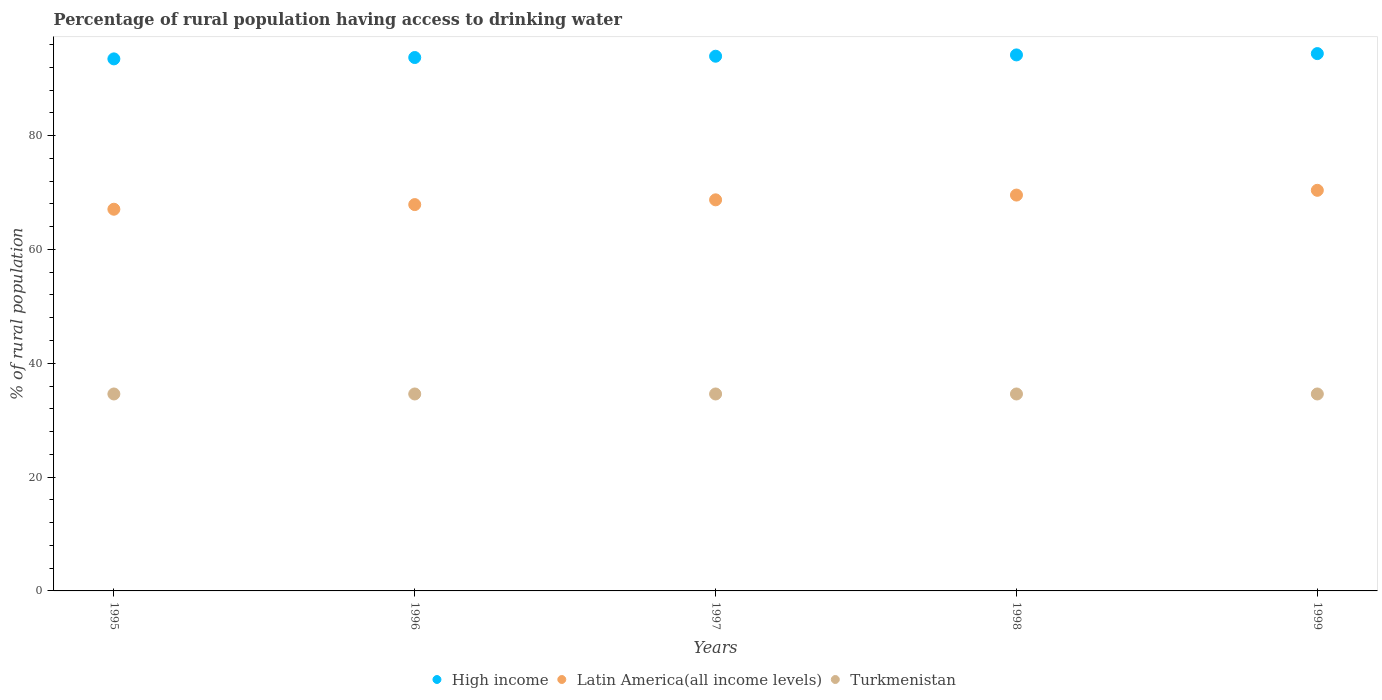Is the number of dotlines equal to the number of legend labels?
Provide a short and direct response. Yes. What is the percentage of rural population having access to drinking water in High income in 1996?
Give a very brief answer. 93.71. Across all years, what is the maximum percentage of rural population having access to drinking water in Latin America(all income levels)?
Provide a short and direct response. 70.38. Across all years, what is the minimum percentage of rural population having access to drinking water in Latin America(all income levels)?
Make the answer very short. 67.06. In which year was the percentage of rural population having access to drinking water in Turkmenistan maximum?
Your answer should be compact. 1995. What is the total percentage of rural population having access to drinking water in High income in the graph?
Make the answer very short. 469.68. What is the difference between the percentage of rural population having access to drinking water in Latin America(all income levels) in 1998 and the percentage of rural population having access to drinking water in High income in 1997?
Offer a very short reply. -24.39. What is the average percentage of rural population having access to drinking water in High income per year?
Offer a very short reply. 93.94. In the year 1996, what is the difference between the percentage of rural population having access to drinking water in High income and percentage of rural population having access to drinking water in Latin America(all income levels)?
Provide a succinct answer. 25.84. In how many years, is the percentage of rural population having access to drinking water in Turkmenistan greater than 20 %?
Ensure brevity in your answer.  5. What is the ratio of the percentage of rural population having access to drinking water in Latin America(all income levels) in 1997 to that in 1999?
Keep it short and to the point. 0.98. Is the percentage of rural population having access to drinking water in Turkmenistan in 1995 less than that in 1999?
Your response must be concise. No. What is the difference between the highest and the second highest percentage of rural population having access to drinking water in High income?
Offer a very short reply. 0.23. In how many years, is the percentage of rural population having access to drinking water in Turkmenistan greater than the average percentage of rural population having access to drinking water in Turkmenistan taken over all years?
Give a very brief answer. 0. Is the sum of the percentage of rural population having access to drinking water in Turkmenistan in 1997 and 1999 greater than the maximum percentage of rural population having access to drinking water in High income across all years?
Keep it short and to the point. No. Is it the case that in every year, the sum of the percentage of rural population having access to drinking water in Turkmenistan and percentage of rural population having access to drinking water in Latin America(all income levels)  is greater than the percentage of rural population having access to drinking water in High income?
Provide a short and direct response. Yes. Does the percentage of rural population having access to drinking water in High income monotonically increase over the years?
Make the answer very short. Yes. Is the percentage of rural population having access to drinking water in Latin America(all income levels) strictly less than the percentage of rural population having access to drinking water in Turkmenistan over the years?
Provide a succinct answer. No. How many dotlines are there?
Your answer should be compact. 3. How many years are there in the graph?
Provide a succinct answer. 5. What is the difference between two consecutive major ticks on the Y-axis?
Give a very brief answer. 20. How many legend labels are there?
Offer a terse response. 3. How are the legend labels stacked?
Give a very brief answer. Horizontal. What is the title of the graph?
Offer a very short reply. Percentage of rural population having access to drinking water. What is the label or title of the X-axis?
Ensure brevity in your answer.  Years. What is the label or title of the Y-axis?
Your answer should be very brief. % of rural population. What is the % of rural population of High income in 1995?
Your response must be concise. 93.47. What is the % of rural population of Latin America(all income levels) in 1995?
Make the answer very short. 67.06. What is the % of rural population in Turkmenistan in 1995?
Your answer should be compact. 34.6. What is the % of rural population in High income in 1996?
Your response must be concise. 93.71. What is the % of rural population of Latin America(all income levels) in 1996?
Give a very brief answer. 67.87. What is the % of rural population in Turkmenistan in 1996?
Provide a short and direct response. 34.6. What is the % of rural population of High income in 1997?
Provide a succinct answer. 93.94. What is the % of rural population in Latin America(all income levels) in 1997?
Your answer should be very brief. 68.71. What is the % of rural population in Turkmenistan in 1997?
Make the answer very short. 34.6. What is the % of rural population in High income in 1998?
Ensure brevity in your answer.  94.17. What is the % of rural population of Latin America(all income levels) in 1998?
Your response must be concise. 69.54. What is the % of rural population in Turkmenistan in 1998?
Keep it short and to the point. 34.6. What is the % of rural population of High income in 1999?
Offer a terse response. 94.4. What is the % of rural population of Latin America(all income levels) in 1999?
Provide a short and direct response. 70.38. What is the % of rural population of Turkmenistan in 1999?
Ensure brevity in your answer.  34.6. Across all years, what is the maximum % of rural population in High income?
Your response must be concise. 94.4. Across all years, what is the maximum % of rural population in Latin America(all income levels)?
Your answer should be compact. 70.38. Across all years, what is the maximum % of rural population in Turkmenistan?
Provide a succinct answer. 34.6. Across all years, what is the minimum % of rural population in High income?
Ensure brevity in your answer.  93.47. Across all years, what is the minimum % of rural population of Latin America(all income levels)?
Provide a short and direct response. 67.06. Across all years, what is the minimum % of rural population of Turkmenistan?
Offer a very short reply. 34.6. What is the total % of rural population of High income in the graph?
Provide a succinct answer. 469.68. What is the total % of rural population of Latin America(all income levels) in the graph?
Keep it short and to the point. 343.56. What is the total % of rural population of Turkmenistan in the graph?
Offer a terse response. 173. What is the difference between the % of rural population in High income in 1995 and that in 1996?
Give a very brief answer. -0.24. What is the difference between the % of rural population of Latin America(all income levels) in 1995 and that in 1996?
Your answer should be very brief. -0.82. What is the difference between the % of rural population in High income in 1995 and that in 1997?
Your response must be concise. -0.47. What is the difference between the % of rural population in Latin America(all income levels) in 1995 and that in 1997?
Offer a very short reply. -1.65. What is the difference between the % of rural population of High income in 1995 and that in 1998?
Make the answer very short. -0.7. What is the difference between the % of rural population of Latin America(all income levels) in 1995 and that in 1998?
Offer a very short reply. -2.49. What is the difference between the % of rural population in Turkmenistan in 1995 and that in 1998?
Your response must be concise. 0. What is the difference between the % of rural population in High income in 1995 and that in 1999?
Your answer should be compact. -0.93. What is the difference between the % of rural population in Latin America(all income levels) in 1995 and that in 1999?
Ensure brevity in your answer.  -3.32. What is the difference between the % of rural population in Turkmenistan in 1995 and that in 1999?
Give a very brief answer. 0. What is the difference between the % of rural population in High income in 1996 and that in 1997?
Your answer should be compact. -0.23. What is the difference between the % of rural population of Latin America(all income levels) in 1996 and that in 1997?
Your answer should be compact. -0.84. What is the difference between the % of rural population of Turkmenistan in 1996 and that in 1997?
Keep it short and to the point. 0. What is the difference between the % of rural population of High income in 1996 and that in 1998?
Give a very brief answer. -0.46. What is the difference between the % of rural population of Latin America(all income levels) in 1996 and that in 1998?
Offer a very short reply. -1.67. What is the difference between the % of rural population in High income in 1996 and that in 1999?
Keep it short and to the point. -0.69. What is the difference between the % of rural population of Latin America(all income levels) in 1996 and that in 1999?
Keep it short and to the point. -2.51. What is the difference between the % of rural population of Turkmenistan in 1996 and that in 1999?
Provide a short and direct response. 0. What is the difference between the % of rural population of High income in 1997 and that in 1998?
Give a very brief answer. -0.23. What is the difference between the % of rural population in Latin America(all income levels) in 1997 and that in 1998?
Provide a succinct answer. -0.84. What is the difference between the % of rural population of Turkmenistan in 1997 and that in 1998?
Make the answer very short. 0. What is the difference between the % of rural population in High income in 1997 and that in 1999?
Your answer should be compact. -0.46. What is the difference between the % of rural population in Latin America(all income levels) in 1997 and that in 1999?
Ensure brevity in your answer.  -1.67. What is the difference between the % of rural population in Turkmenistan in 1997 and that in 1999?
Your response must be concise. 0. What is the difference between the % of rural population of High income in 1998 and that in 1999?
Give a very brief answer. -0.23. What is the difference between the % of rural population of Latin America(all income levels) in 1998 and that in 1999?
Ensure brevity in your answer.  -0.84. What is the difference between the % of rural population in High income in 1995 and the % of rural population in Latin America(all income levels) in 1996?
Keep it short and to the point. 25.6. What is the difference between the % of rural population in High income in 1995 and the % of rural population in Turkmenistan in 1996?
Make the answer very short. 58.87. What is the difference between the % of rural population in Latin America(all income levels) in 1995 and the % of rural population in Turkmenistan in 1996?
Offer a terse response. 32.46. What is the difference between the % of rural population of High income in 1995 and the % of rural population of Latin America(all income levels) in 1997?
Make the answer very short. 24.76. What is the difference between the % of rural population of High income in 1995 and the % of rural population of Turkmenistan in 1997?
Offer a terse response. 58.87. What is the difference between the % of rural population in Latin America(all income levels) in 1995 and the % of rural population in Turkmenistan in 1997?
Ensure brevity in your answer.  32.46. What is the difference between the % of rural population in High income in 1995 and the % of rural population in Latin America(all income levels) in 1998?
Your answer should be compact. 23.93. What is the difference between the % of rural population in High income in 1995 and the % of rural population in Turkmenistan in 1998?
Your answer should be very brief. 58.87. What is the difference between the % of rural population of Latin America(all income levels) in 1995 and the % of rural population of Turkmenistan in 1998?
Offer a very short reply. 32.46. What is the difference between the % of rural population in High income in 1995 and the % of rural population in Latin America(all income levels) in 1999?
Your answer should be compact. 23.09. What is the difference between the % of rural population in High income in 1995 and the % of rural population in Turkmenistan in 1999?
Provide a succinct answer. 58.87. What is the difference between the % of rural population in Latin America(all income levels) in 1995 and the % of rural population in Turkmenistan in 1999?
Your answer should be compact. 32.46. What is the difference between the % of rural population in High income in 1996 and the % of rural population in Latin America(all income levels) in 1997?
Keep it short and to the point. 25. What is the difference between the % of rural population in High income in 1996 and the % of rural population in Turkmenistan in 1997?
Make the answer very short. 59.11. What is the difference between the % of rural population of Latin America(all income levels) in 1996 and the % of rural population of Turkmenistan in 1997?
Your answer should be very brief. 33.27. What is the difference between the % of rural population in High income in 1996 and the % of rural population in Latin America(all income levels) in 1998?
Provide a succinct answer. 24.17. What is the difference between the % of rural population of High income in 1996 and the % of rural population of Turkmenistan in 1998?
Provide a succinct answer. 59.11. What is the difference between the % of rural population in Latin America(all income levels) in 1996 and the % of rural population in Turkmenistan in 1998?
Keep it short and to the point. 33.27. What is the difference between the % of rural population in High income in 1996 and the % of rural population in Latin America(all income levels) in 1999?
Your response must be concise. 23.33. What is the difference between the % of rural population of High income in 1996 and the % of rural population of Turkmenistan in 1999?
Your answer should be compact. 59.11. What is the difference between the % of rural population in Latin America(all income levels) in 1996 and the % of rural population in Turkmenistan in 1999?
Offer a terse response. 33.27. What is the difference between the % of rural population of High income in 1997 and the % of rural population of Latin America(all income levels) in 1998?
Offer a very short reply. 24.39. What is the difference between the % of rural population of High income in 1997 and the % of rural population of Turkmenistan in 1998?
Offer a very short reply. 59.34. What is the difference between the % of rural population in Latin America(all income levels) in 1997 and the % of rural population in Turkmenistan in 1998?
Offer a very short reply. 34.11. What is the difference between the % of rural population of High income in 1997 and the % of rural population of Latin America(all income levels) in 1999?
Keep it short and to the point. 23.56. What is the difference between the % of rural population in High income in 1997 and the % of rural population in Turkmenistan in 1999?
Ensure brevity in your answer.  59.34. What is the difference between the % of rural population of Latin America(all income levels) in 1997 and the % of rural population of Turkmenistan in 1999?
Your answer should be compact. 34.11. What is the difference between the % of rural population in High income in 1998 and the % of rural population in Latin America(all income levels) in 1999?
Offer a very short reply. 23.79. What is the difference between the % of rural population of High income in 1998 and the % of rural population of Turkmenistan in 1999?
Give a very brief answer. 59.57. What is the difference between the % of rural population in Latin America(all income levels) in 1998 and the % of rural population in Turkmenistan in 1999?
Make the answer very short. 34.94. What is the average % of rural population of High income per year?
Your answer should be very brief. 93.94. What is the average % of rural population of Latin America(all income levels) per year?
Provide a short and direct response. 68.71. What is the average % of rural population of Turkmenistan per year?
Keep it short and to the point. 34.6. In the year 1995, what is the difference between the % of rural population of High income and % of rural population of Latin America(all income levels)?
Offer a very short reply. 26.41. In the year 1995, what is the difference between the % of rural population in High income and % of rural population in Turkmenistan?
Offer a terse response. 58.87. In the year 1995, what is the difference between the % of rural population in Latin America(all income levels) and % of rural population in Turkmenistan?
Keep it short and to the point. 32.46. In the year 1996, what is the difference between the % of rural population in High income and % of rural population in Latin America(all income levels)?
Provide a succinct answer. 25.84. In the year 1996, what is the difference between the % of rural population of High income and % of rural population of Turkmenistan?
Provide a succinct answer. 59.11. In the year 1996, what is the difference between the % of rural population in Latin America(all income levels) and % of rural population in Turkmenistan?
Your response must be concise. 33.27. In the year 1997, what is the difference between the % of rural population of High income and % of rural population of Latin America(all income levels)?
Your response must be concise. 25.23. In the year 1997, what is the difference between the % of rural population of High income and % of rural population of Turkmenistan?
Offer a terse response. 59.34. In the year 1997, what is the difference between the % of rural population of Latin America(all income levels) and % of rural population of Turkmenistan?
Your answer should be very brief. 34.11. In the year 1998, what is the difference between the % of rural population of High income and % of rural population of Latin America(all income levels)?
Keep it short and to the point. 24.62. In the year 1998, what is the difference between the % of rural population in High income and % of rural population in Turkmenistan?
Your response must be concise. 59.57. In the year 1998, what is the difference between the % of rural population of Latin America(all income levels) and % of rural population of Turkmenistan?
Provide a succinct answer. 34.94. In the year 1999, what is the difference between the % of rural population in High income and % of rural population in Latin America(all income levels)?
Provide a succinct answer. 24.02. In the year 1999, what is the difference between the % of rural population of High income and % of rural population of Turkmenistan?
Ensure brevity in your answer.  59.8. In the year 1999, what is the difference between the % of rural population in Latin America(all income levels) and % of rural population in Turkmenistan?
Ensure brevity in your answer.  35.78. What is the ratio of the % of rural population of Latin America(all income levels) in 1995 to that in 1996?
Make the answer very short. 0.99. What is the ratio of the % of rural population of High income in 1995 to that in 1998?
Your answer should be very brief. 0.99. What is the ratio of the % of rural population in Latin America(all income levels) in 1995 to that in 1998?
Provide a succinct answer. 0.96. What is the ratio of the % of rural population of High income in 1995 to that in 1999?
Give a very brief answer. 0.99. What is the ratio of the % of rural population in Latin America(all income levels) in 1995 to that in 1999?
Offer a very short reply. 0.95. What is the ratio of the % of rural population in High income in 1996 to that in 1997?
Provide a succinct answer. 1. What is the ratio of the % of rural population of Latin America(all income levels) in 1996 to that in 1997?
Your answer should be compact. 0.99. What is the ratio of the % of rural population in Turkmenistan in 1996 to that in 1997?
Ensure brevity in your answer.  1. What is the ratio of the % of rural population in High income in 1996 to that in 1998?
Keep it short and to the point. 1. What is the ratio of the % of rural population of Latin America(all income levels) in 1996 to that in 1998?
Make the answer very short. 0.98. What is the ratio of the % of rural population of High income in 1996 to that in 1999?
Provide a short and direct response. 0.99. What is the ratio of the % of rural population in Latin America(all income levels) in 1996 to that in 1999?
Your answer should be very brief. 0.96. What is the ratio of the % of rural population of High income in 1997 to that in 1999?
Give a very brief answer. 1. What is the ratio of the % of rural population of Latin America(all income levels) in 1997 to that in 1999?
Give a very brief answer. 0.98. What is the ratio of the % of rural population of Turkmenistan in 1997 to that in 1999?
Your answer should be compact. 1. What is the ratio of the % of rural population in Latin America(all income levels) in 1998 to that in 1999?
Your response must be concise. 0.99. What is the ratio of the % of rural population in Turkmenistan in 1998 to that in 1999?
Offer a terse response. 1. What is the difference between the highest and the second highest % of rural population of High income?
Offer a very short reply. 0.23. What is the difference between the highest and the second highest % of rural population of Latin America(all income levels)?
Your answer should be very brief. 0.84. What is the difference between the highest and the second highest % of rural population of Turkmenistan?
Ensure brevity in your answer.  0. What is the difference between the highest and the lowest % of rural population of High income?
Your answer should be very brief. 0.93. What is the difference between the highest and the lowest % of rural population in Latin America(all income levels)?
Your answer should be very brief. 3.32. 